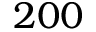<formula> <loc_0><loc_0><loc_500><loc_500>2 0 0</formula> 